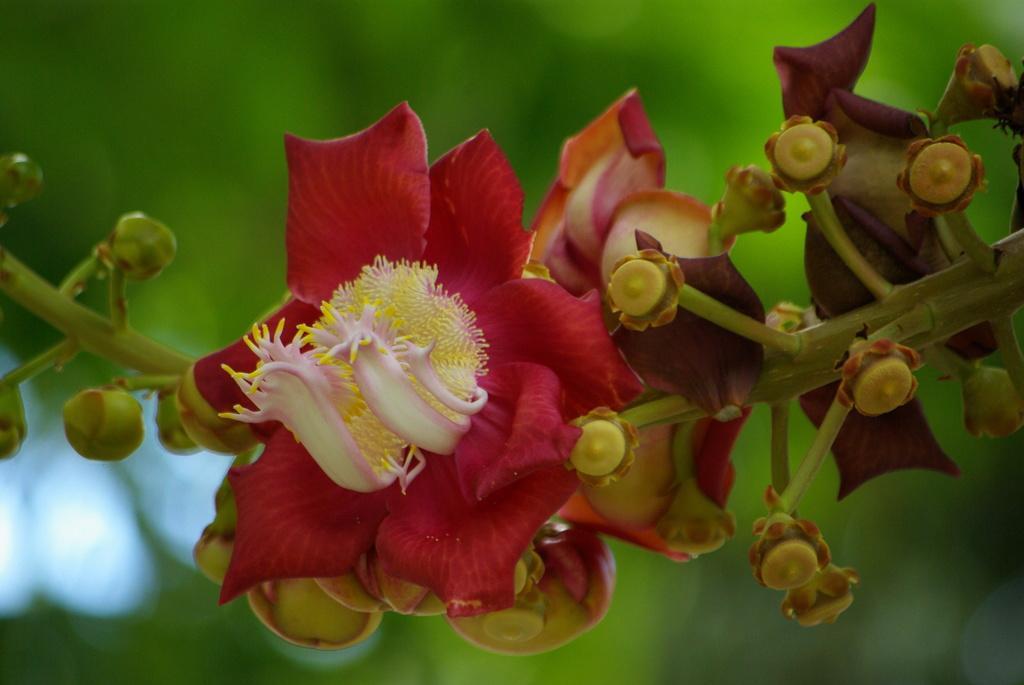In one or two sentences, can you explain what this image depicts? In this image we can see flowers and stem. In the background, we can see greenery. 